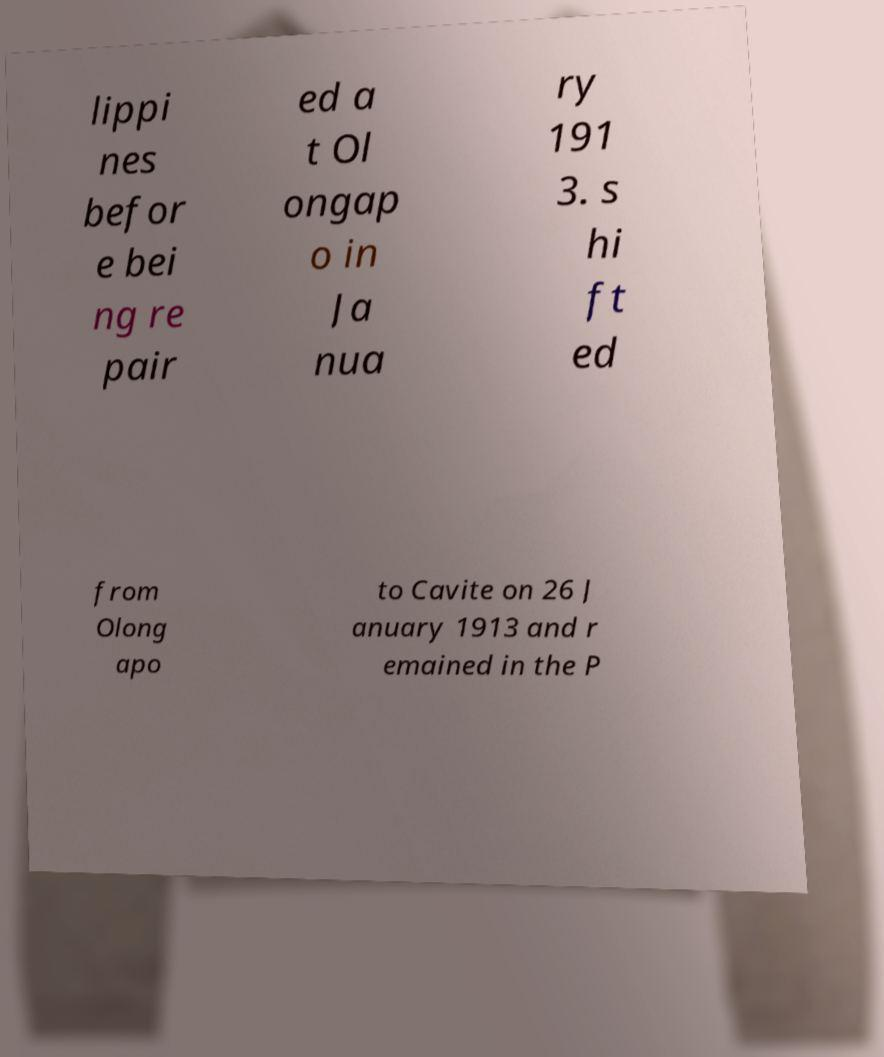I need the written content from this picture converted into text. Can you do that? lippi nes befor e bei ng re pair ed a t Ol ongap o in Ja nua ry 191 3. s hi ft ed from Olong apo to Cavite on 26 J anuary 1913 and r emained in the P 